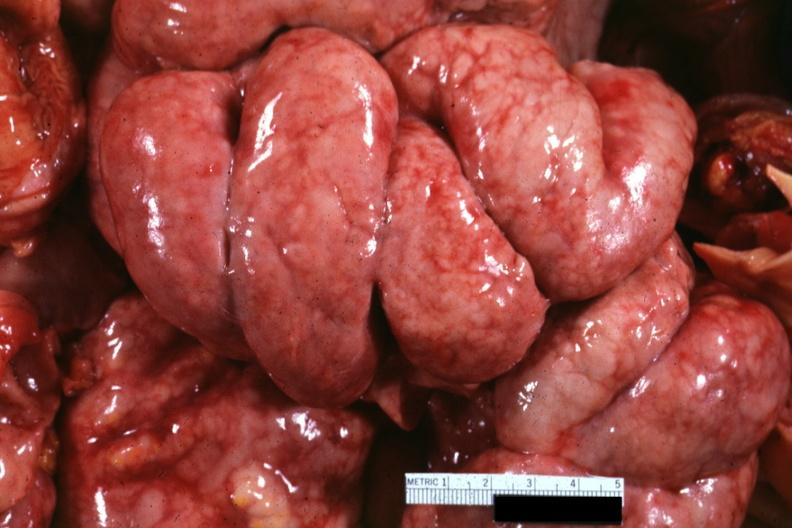why does this image show bowel in situ with diffuse thickening of peritoneal surfaces?
Answer the question using a single word or phrase. Due to metastatic carcinoma breast primary i think 